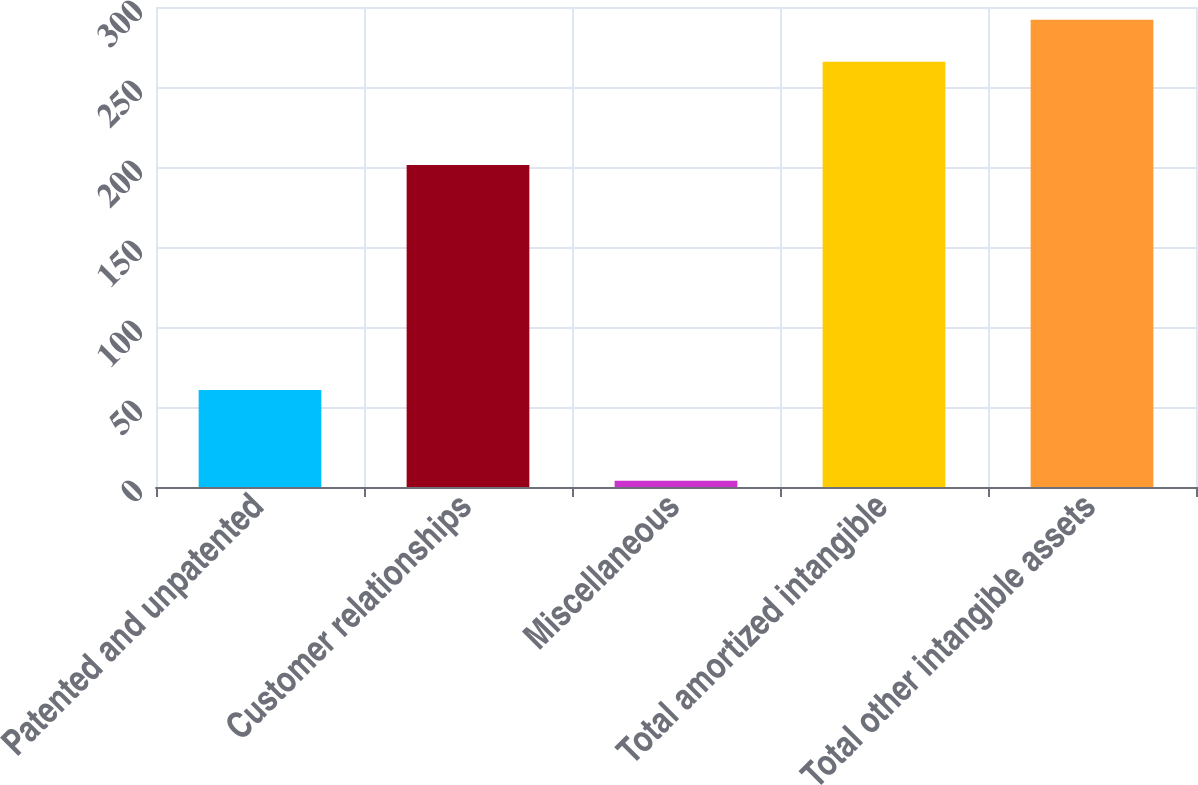Convert chart. <chart><loc_0><loc_0><loc_500><loc_500><bar_chart><fcel>Patented and unpatented<fcel>Customer relationships<fcel>Miscellaneous<fcel>Total amortized intangible<fcel>Total other intangible assets<nl><fcel>60.7<fcel>201.2<fcel>3.9<fcel>265.8<fcel>291.99<nl></chart> 